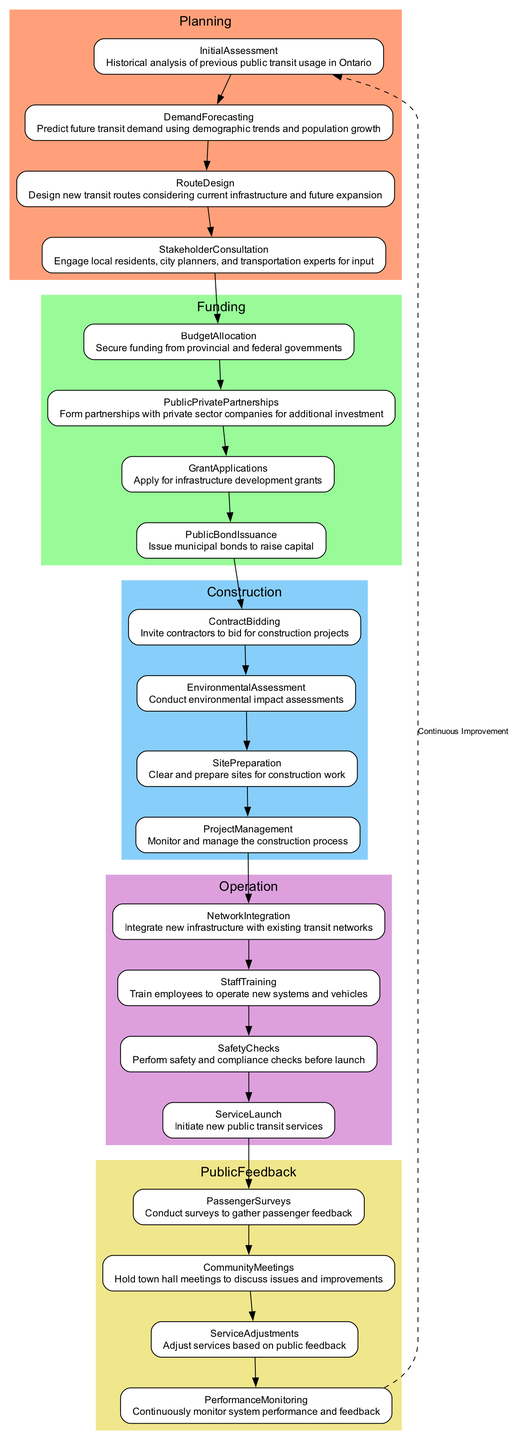What is the first step in the Planning phase? The first step in the Planning phase is "InitialAssessment", which involves a historical analysis of previous public transit usage in Ontario.
Answer: InitialAssessment How many steps are in the Funding phase? The Funding phase includes four steps: BudgetAllocation, PublicPrivatePartnerships, GrantApplications, and PublicBondIssuance.
Answer: 4 What connects the last step of Operation to the first step of Planning? The last step of Operation is "ServiceLaunch", and it connects to the first step of Planning through a dashed line labeled 'Continuous Improvement', indicating a feedback loop for ongoing development.
Answer: Continuous Improvement Which step follows EnvironmentalAssessment in the Construction phase? The step that follows EnvironmentalAssessment is "SitePreparation", indicating the sequence in which steps are conducted in the construction process.
Answer: SitePreparation How many phases are there in the flowchart? The flowchart features five distinct phases: Planning, Funding, Construction, Operation, and PublicFeedback.
Answer: 5 What type of meetings are held in the Public Feedback phase? The meetings held in the Public Feedback phase are called "CommunityMeetings", which aim to discuss issues and improvements directly with the public.
Answer: CommunityMeetings Which phase includes the task "PassengerSurveys"? The task "PassengerSurveys" is part of the PublicFeedback phase, where surveys are conducted to gather feedback from transit passengers.
Answer: PublicFeedback What are the connecting steps between Funding and Construction? The connection between Funding and Construction is established through the last step of Funding, "PublicBondIssuance", which leads to the first step of Construction, "ContractBidding".
Answer: PublicBondIssuance and ContractBidding Which step in the Operation phase is concerned with safety? The step in the Operation phase that is focused on safety is "SafetyChecks", which involves performing safety and compliance checks before launching new services.
Answer: SafetyChecks 